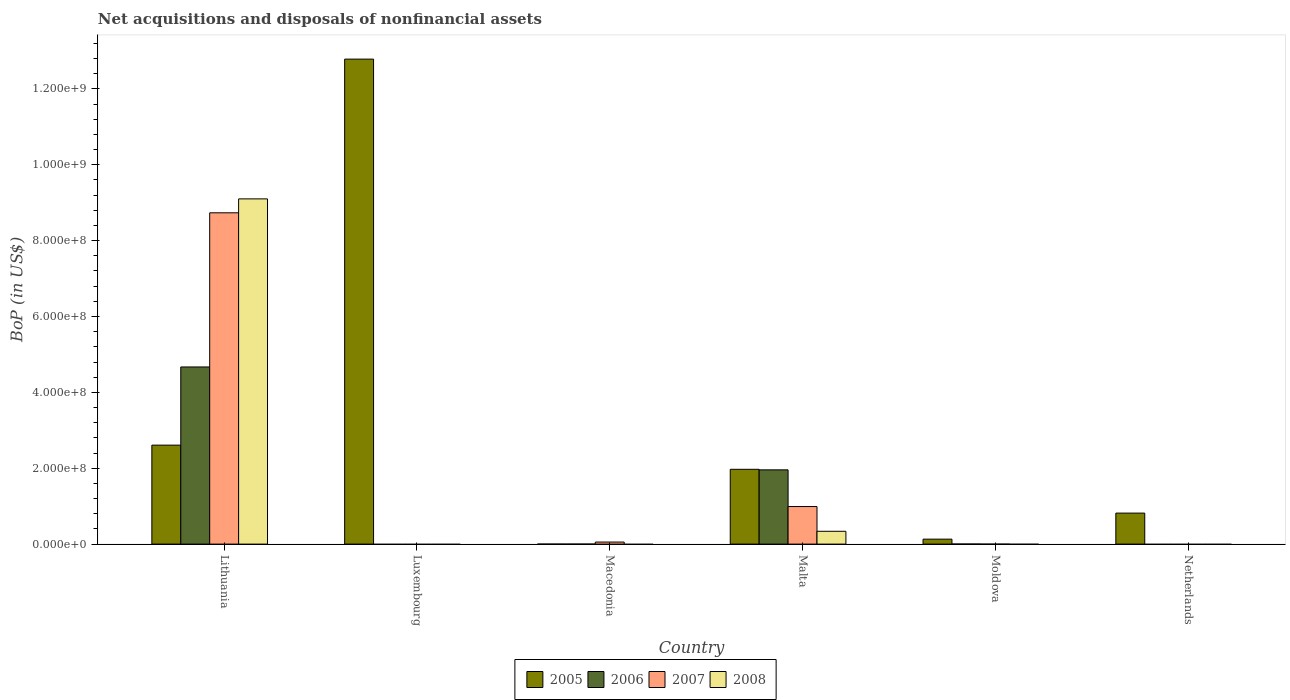How many different coloured bars are there?
Offer a very short reply. 4. Are the number of bars per tick equal to the number of legend labels?
Your answer should be compact. No. What is the label of the 3rd group of bars from the left?
Keep it short and to the point. Macedonia. In how many cases, is the number of bars for a given country not equal to the number of legend labels?
Offer a very short reply. 4. What is the Balance of Payments in 2005 in Macedonia?
Your answer should be very brief. 7057.87. Across all countries, what is the maximum Balance of Payments in 2008?
Give a very brief answer. 9.10e+08. In which country was the Balance of Payments in 2005 maximum?
Make the answer very short. Luxembourg. What is the total Balance of Payments in 2007 in the graph?
Make the answer very short. 9.78e+08. What is the difference between the Balance of Payments in 2005 in Macedonia and that in Moldova?
Your response must be concise. -1.30e+07. What is the difference between the Balance of Payments in 2005 in Luxembourg and the Balance of Payments in 2008 in Macedonia?
Offer a very short reply. 1.28e+09. What is the average Balance of Payments in 2007 per country?
Make the answer very short. 1.63e+08. What is the difference between the Balance of Payments of/in 2008 and Balance of Payments of/in 2007 in Lithuania?
Your response must be concise. 3.67e+07. What is the ratio of the Balance of Payments in 2005 in Moldova to that in Netherlands?
Keep it short and to the point. 0.16. What is the difference between the highest and the second highest Balance of Payments in 2006?
Ensure brevity in your answer.  -4.67e+08. What is the difference between the highest and the lowest Balance of Payments in 2005?
Provide a succinct answer. 1.28e+09. In how many countries, is the Balance of Payments in 2007 greater than the average Balance of Payments in 2007 taken over all countries?
Make the answer very short. 1. Is the sum of the Balance of Payments in 2007 in Lithuania and Macedonia greater than the maximum Balance of Payments in 2005 across all countries?
Provide a succinct answer. No. Is it the case that in every country, the sum of the Balance of Payments in 2007 and Balance of Payments in 2005 is greater than the sum of Balance of Payments in 2006 and Balance of Payments in 2008?
Provide a short and direct response. No. Is it the case that in every country, the sum of the Balance of Payments in 2008 and Balance of Payments in 2005 is greater than the Balance of Payments in 2007?
Make the answer very short. No. How many bars are there?
Your answer should be compact. 15. Are all the bars in the graph horizontal?
Make the answer very short. No. What is the difference between two consecutive major ticks on the Y-axis?
Your answer should be very brief. 2.00e+08. Are the values on the major ticks of Y-axis written in scientific E-notation?
Give a very brief answer. Yes. Does the graph contain grids?
Provide a succinct answer. No. How many legend labels are there?
Your response must be concise. 4. How are the legend labels stacked?
Make the answer very short. Horizontal. What is the title of the graph?
Your answer should be compact. Net acquisitions and disposals of nonfinancial assets. What is the label or title of the Y-axis?
Give a very brief answer. BoP (in US$). What is the BoP (in US$) in 2005 in Lithuania?
Make the answer very short. 2.61e+08. What is the BoP (in US$) in 2006 in Lithuania?
Keep it short and to the point. 4.67e+08. What is the BoP (in US$) in 2007 in Lithuania?
Make the answer very short. 8.73e+08. What is the BoP (in US$) in 2008 in Lithuania?
Your answer should be very brief. 9.10e+08. What is the BoP (in US$) in 2005 in Luxembourg?
Provide a short and direct response. 1.28e+09. What is the BoP (in US$) in 2006 in Luxembourg?
Provide a short and direct response. 0. What is the BoP (in US$) in 2007 in Luxembourg?
Ensure brevity in your answer.  0. What is the BoP (in US$) in 2005 in Macedonia?
Keep it short and to the point. 7057.87. What is the BoP (in US$) of 2006 in Macedonia?
Your response must be concise. 4585.23. What is the BoP (in US$) in 2007 in Macedonia?
Your response must be concise. 5.40e+06. What is the BoP (in US$) in 2005 in Malta?
Provide a succinct answer. 1.97e+08. What is the BoP (in US$) in 2006 in Malta?
Offer a very short reply. 1.96e+08. What is the BoP (in US$) in 2007 in Malta?
Make the answer very short. 9.90e+07. What is the BoP (in US$) of 2008 in Malta?
Provide a short and direct response. 3.38e+07. What is the BoP (in US$) of 2005 in Moldova?
Provide a succinct answer. 1.30e+07. What is the BoP (in US$) of 2006 in Moldova?
Give a very brief answer. 1.60e+05. What is the BoP (in US$) of 2008 in Moldova?
Provide a short and direct response. 0. What is the BoP (in US$) in 2005 in Netherlands?
Offer a terse response. 8.17e+07. What is the BoP (in US$) of 2006 in Netherlands?
Give a very brief answer. 0. What is the BoP (in US$) in 2007 in Netherlands?
Make the answer very short. 0. What is the BoP (in US$) in 2008 in Netherlands?
Provide a succinct answer. 0. Across all countries, what is the maximum BoP (in US$) in 2005?
Give a very brief answer. 1.28e+09. Across all countries, what is the maximum BoP (in US$) of 2006?
Your answer should be compact. 4.67e+08. Across all countries, what is the maximum BoP (in US$) in 2007?
Give a very brief answer. 8.73e+08. Across all countries, what is the maximum BoP (in US$) in 2008?
Your answer should be very brief. 9.10e+08. Across all countries, what is the minimum BoP (in US$) of 2005?
Your answer should be compact. 7057.87. Across all countries, what is the minimum BoP (in US$) of 2007?
Ensure brevity in your answer.  0. What is the total BoP (in US$) in 2005 in the graph?
Offer a terse response. 1.83e+09. What is the total BoP (in US$) in 2006 in the graph?
Your answer should be compact. 6.63e+08. What is the total BoP (in US$) of 2007 in the graph?
Give a very brief answer. 9.78e+08. What is the total BoP (in US$) in 2008 in the graph?
Provide a short and direct response. 9.44e+08. What is the difference between the BoP (in US$) of 2005 in Lithuania and that in Luxembourg?
Your answer should be very brief. -1.02e+09. What is the difference between the BoP (in US$) in 2005 in Lithuania and that in Macedonia?
Your answer should be very brief. 2.61e+08. What is the difference between the BoP (in US$) in 2006 in Lithuania and that in Macedonia?
Keep it short and to the point. 4.67e+08. What is the difference between the BoP (in US$) of 2007 in Lithuania and that in Macedonia?
Offer a very short reply. 8.68e+08. What is the difference between the BoP (in US$) of 2005 in Lithuania and that in Malta?
Your answer should be compact. 6.37e+07. What is the difference between the BoP (in US$) in 2006 in Lithuania and that in Malta?
Give a very brief answer. 2.71e+08. What is the difference between the BoP (in US$) of 2007 in Lithuania and that in Malta?
Ensure brevity in your answer.  7.74e+08. What is the difference between the BoP (in US$) in 2008 in Lithuania and that in Malta?
Offer a terse response. 8.76e+08. What is the difference between the BoP (in US$) of 2005 in Lithuania and that in Moldova?
Offer a very short reply. 2.48e+08. What is the difference between the BoP (in US$) of 2006 in Lithuania and that in Moldova?
Ensure brevity in your answer.  4.67e+08. What is the difference between the BoP (in US$) of 2005 in Lithuania and that in Netherlands?
Your answer should be compact. 1.79e+08. What is the difference between the BoP (in US$) in 2005 in Luxembourg and that in Macedonia?
Offer a very short reply. 1.28e+09. What is the difference between the BoP (in US$) of 2005 in Luxembourg and that in Malta?
Your answer should be compact. 1.08e+09. What is the difference between the BoP (in US$) of 2005 in Luxembourg and that in Moldova?
Offer a terse response. 1.27e+09. What is the difference between the BoP (in US$) in 2005 in Luxembourg and that in Netherlands?
Make the answer very short. 1.20e+09. What is the difference between the BoP (in US$) of 2005 in Macedonia and that in Malta?
Your response must be concise. -1.97e+08. What is the difference between the BoP (in US$) of 2006 in Macedonia and that in Malta?
Offer a very short reply. -1.96e+08. What is the difference between the BoP (in US$) of 2007 in Macedonia and that in Malta?
Provide a succinct answer. -9.36e+07. What is the difference between the BoP (in US$) in 2005 in Macedonia and that in Moldova?
Your answer should be compact. -1.30e+07. What is the difference between the BoP (in US$) in 2006 in Macedonia and that in Moldova?
Keep it short and to the point. -1.55e+05. What is the difference between the BoP (in US$) in 2005 in Macedonia and that in Netherlands?
Offer a terse response. -8.17e+07. What is the difference between the BoP (in US$) of 2005 in Malta and that in Moldova?
Make the answer very short. 1.84e+08. What is the difference between the BoP (in US$) in 2006 in Malta and that in Moldova?
Give a very brief answer. 1.96e+08. What is the difference between the BoP (in US$) of 2005 in Malta and that in Netherlands?
Your response must be concise. 1.15e+08. What is the difference between the BoP (in US$) of 2005 in Moldova and that in Netherlands?
Your response must be concise. -6.87e+07. What is the difference between the BoP (in US$) of 2005 in Lithuania and the BoP (in US$) of 2006 in Macedonia?
Offer a terse response. 2.61e+08. What is the difference between the BoP (in US$) in 2005 in Lithuania and the BoP (in US$) in 2007 in Macedonia?
Your response must be concise. 2.55e+08. What is the difference between the BoP (in US$) of 2006 in Lithuania and the BoP (in US$) of 2007 in Macedonia?
Give a very brief answer. 4.62e+08. What is the difference between the BoP (in US$) in 2005 in Lithuania and the BoP (in US$) in 2006 in Malta?
Keep it short and to the point. 6.51e+07. What is the difference between the BoP (in US$) of 2005 in Lithuania and the BoP (in US$) of 2007 in Malta?
Your response must be concise. 1.62e+08. What is the difference between the BoP (in US$) of 2005 in Lithuania and the BoP (in US$) of 2008 in Malta?
Ensure brevity in your answer.  2.27e+08. What is the difference between the BoP (in US$) in 2006 in Lithuania and the BoP (in US$) in 2007 in Malta?
Provide a succinct answer. 3.68e+08. What is the difference between the BoP (in US$) of 2006 in Lithuania and the BoP (in US$) of 2008 in Malta?
Make the answer very short. 4.33e+08. What is the difference between the BoP (in US$) of 2007 in Lithuania and the BoP (in US$) of 2008 in Malta?
Offer a terse response. 8.40e+08. What is the difference between the BoP (in US$) in 2005 in Lithuania and the BoP (in US$) in 2006 in Moldova?
Your answer should be compact. 2.61e+08. What is the difference between the BoP (in US$) in 2005 in Luxembourg and the BoP (in US$) in 2006 in Macedonia?
Offer a terse response. 1.28e+09. What is the difference between the BoP (in US$) of 2005 in Luxembourg and the BoP (in US$) of 2007 in Macedonia?
Provide a succinct answer. 1.27e+09. What is the difference between the BoP (in US$) of 2005 in Luxembourg and the BoP (in US$) of 2006 in Malta?
Give a very brief answer. 1.08e+09. What is the difference between the BoP (in US$) of 2005 in Luxembourg and the BoP (in US$) of 2007 in Malta?
Provide a short and direct response. 1.18e+09. What is the difference between the BoP (in US$) in 2005 in Luxembourg and the BoP (in US$) in 2008 in Malta?
Your answer should be very brief. 1.24e+09. What is the difference between the BoP (in US$) in 2005 in Luxembourg and the BoP (in US$) in 2006 in Moldova?
Provide a short and direct response. 1.28e+09. What is the difference between the BoP (in US$) of 2005 in Macedonia and the BoP (in US$) of 2006 in Malta?
Make the answer very short. -1.96e+08. What is the difference between the BoP (in US$) of 2005 in Macedonia and the BoP (in US$) of 2007 in Malta?
Give a very brief answer. -9.90e+07. What is the difference between the BoP (in US$) in 2005 in Macedonia and the BoP (in US$) in 2008 in Malta?
Provide a succinct answer. -3.38e+07. What is the difference between the BoP (in US$) in 2006 in Macedonia and the BoP (in US$) in 2007 in Malta?
Keep it short and to the point. -9.90e+07. What is the difference between the BoP (in US$) of 2006 in Macedonia and the BoP (in US$) of 2008 in Malta?
Your answer should be very brief. -3.38e+07. What is the difference between the BoP (in US$) in 2007 in Macedonia and the BoP (in US$) in 2008 in Malta?
Provide a succinct answer. -2.84e+07. What is the difference between the BoP (in US$) in 2005 in Macedonia and the BoP (in US$) in 2006 in Moldova?
Offer a very short reply. -1.53e+05. What is the difference between the BoP (in US$) of 2005 in Malta and the BoP (in US$) of 2006 in Moldova?
Provide a succinct answer. 1.97e+08. What is the average BoP (in US$) of 2005 per country?
Provide a short and direct response. 3.05e+08. What is the average BoP (in US$) in 2006 per country?
Offer a very short reply. 1.10e+08. What is the average BoP (in US$) of 2007 per country?
Offer a very short reply. 1.63e+08. What is the average BoP (in US$) in 2008 per country?
Your response must be concise. 1.57e+08. What is the difference between the BoP (in US$) of 2005 and BoP (in US$) of 2006 in Lithuania?
Make the answer very short. -2.06e+08. What is the difference between the BoP (in US$) of 2005 and BoP (in US$) of 2007 in Lithuania?
Your answer should be very brief. -6.12e+08. What is the difference between the BoP (in US$) in 2005 and BoP (in US$) in 2008 in Lithuania?
Your response must be concise. -6.49e+08. What is the difference between the BoP (in US$) in 2006 and BoP (in US$) in 2007 in Lithuania?
Provide a short and direct response. -4.06e+08. What is the difference between the BoP (in US$) of 2006 and BoP (in US$) of 2008 in Lithuania?
Provide a short and direct response. -4.43e+08. What is the difference between the BoP (in US$) of 2007 and BoP (in US$) of 2008 in Lithuania?
Offer a very short reply. -3.67e+07. What is the difference between the BoP (in US$) in 2005 and BoP (in US$) in 2006 in Macedonia?
Ensure brevity in your answer.  2472.64. What is the difference between the BoP (in US$) of 2005 and BoP (in US$) of 2007 in Macedonia?
Your answer should be very brief. -5.39e+06. What is the difference between the BoP (in US$) of 2006 and BoP (in US$) of 2007 in Macedonia?
Provide a short and direct response. -5.40e+06. What is the difference between the BoP (in US$) of 2005 and BoP (in US$) of 2006 in Malta?
Your response must be concise. 1.42e+06. What is the difference between the BoP (in US$) in 2005 and BoP (in US$) in 2007 in Malta?
Your answer should be very brief. 9.81e+07. What is the difference between the BoP (in US$) in 2005 and BoP (in US$) in 2008 in Malta?
Provide a short and direct response. 1.63e+08. What is the difference between the BoP (in US$) of 2006 and BoP (in US$) of 2007 in Malta?
Offer a terse response. 9.67e+07. What is the difference between the BoP (in US$) of 2006 and BoP (in US$) of 2008 in Malta?
Keep it short and to the point. 1.62e+08. What is the difference between the BoP (in US$) in 2007 and BoP (in US$) in 2008 in Malta?
Offer a very short reply. 6.52e+07. What is the difference between the BoP (in US$) in 2005 and BoP (in US$) in 2006 in Moldova?
Ensure brevity in your answer.  1.29e+07. What is the ratio of the BoP (in US$) in 2005 in Lithuania to that in Luxembourg?
Offer a very short reply. 0.2. What is the ratio of the BoP (in US$) of 2005 in Lithuania to that in Macedonia?
Provide a short and direct response. 3.70e+04. What is the ratio of the BoP (in US$) of 2006 in Lithuania to that in Macedonia?
Your answer should be compact. 1.02e+05. What is the ratio of the BoP (in US$) of 2007 in Lithuania to that in Macedonia?
Provide a short and direct response. 161.71. What is the ratio of the BoP (in US$) of 2005 in Lithuania to that in Malta?
Your answer should be compact. 1.32. What is the ratio of the BoP (in US$) in 2006 in Lithuania to that in Malta?
Offer a terse response. 2.39. What is the ratio of the BoP (in US$) of 2007 in Lithuania to that in Malta?
Provide a succinct answer. 8.82. What is the ratio of the BoP (in US$) in 2008 in Lithuania to that in Malta?
Your response must be concise. 26.93. What is the ratio of the BoP (in US$) in 2005 in Lithuania to that in Moldova?
Make the answer very short. 20.01. What is the ratio of the BoP (in US$) in 2006 in Lithuania to that in Moldova?
Your answer should be very brief. 2918.47. What is the ratio of the BoP (in US$) of 2005 in Lithuania to that in Netherlands?
Offer a terse response. 3.19. What is the ratio of the BoP (in US$) of 2005 in Luxembourg to that in Macedonia?
Give a very brief answer. 1.81e+05. What is the ratio of the BoP (in US$) of 2005 in Luxembourg to that in Malta?
Provide a succinct answer. 6.48. What is the ratio of the BoP (in US$) of 2005 in Luxembourg to that in Moldova?
Make the answer very short. 98.04. What is the ratio of the BoP (in US$) in 2005 in Luxembourg to that in Netherlands?
Give a very brief answer. 15.64. What is the ratio of the BoP (in US$) of 2006 in Macedonia to that in Malta?
Give a very brief answer. 0. What is the ratio of the BoP (in US$) in 2007 in Macedonia to that in Malta?
Offer a terse response. 0.05. What is the ratio of the BoP (in US$) in 2005 in Macedonia to that in Moldova?
Ensure brevity in your answer.  0. What is the ratio of the BoP (in US$) of 2006 in Macedonia to that in Moldova?
Keep it short and to the point. 0.03. What is the ratio of the BoP (in US$) in 2005 in Malta to that in Moldova?
Offer a very short reply. 15.12. What is the ratio of the BoP (in US$) of 2006 in Malta to that in Moldova?
Offer a terse response. 1223.36. What is the ratio of the BoP (in US$) of 2005 in Malta to that in Netherlands?
Your answer should be compact. 2.41. What is the ratio of the BoP (in US$) of 2005 in Moldova to that in Netherlands?
Offer a terse response. 0.16. What is the difference between the highest and the second highest BoP (in US$) in 2005?
Keep it short and to the point. 1.02e+09. What is the difference between the highest and the second highest BoP (in US$) of 2006?
Give a very brief answer. 2.71e+08. What is the difference between the highest and the second highest BoP (in US$) of 2007?
Your answer should be compact. 7.74e+08. What is the difference between the highest and the lowest BoP (in US$) of 2005?
Your answer should be compact. 1.28e+09. What is the difference between the highest and the lowest BoP (in US$) of 2006?
Your answer should be very brief. 4.67e+08. What is the difference between the highest and the lowest BoP (in US$) in 2007?
Your answer should be very brief. 8.73e+08. What is the difference between the highest and the lowest BoP (in US$) of 2008?
Keep it short and to the point. 9.10e+08. 